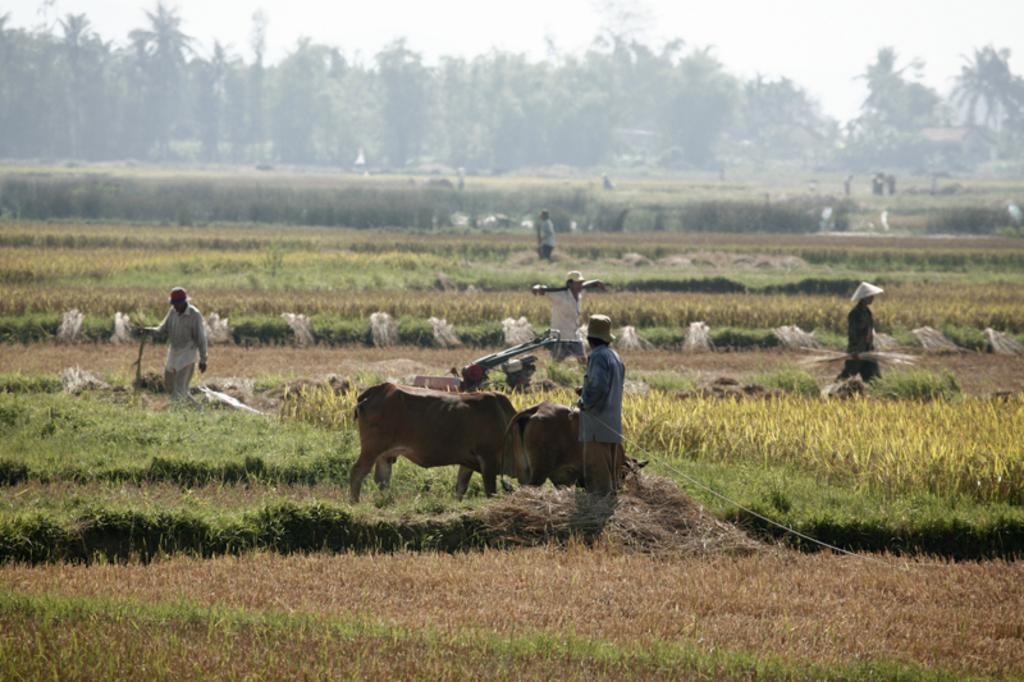How many animals are present in the image? There are two animals in the image. How many people are present in the image? There are five people in the image. Where was the image taken? The image was taken in a field. What can be seen in the background of the image? There are many trees in the background of the image. What type of notebook is being used by the scarecrow in the image? There is no scarecrow present in the image, and therefore no notebook can be associated with it. 